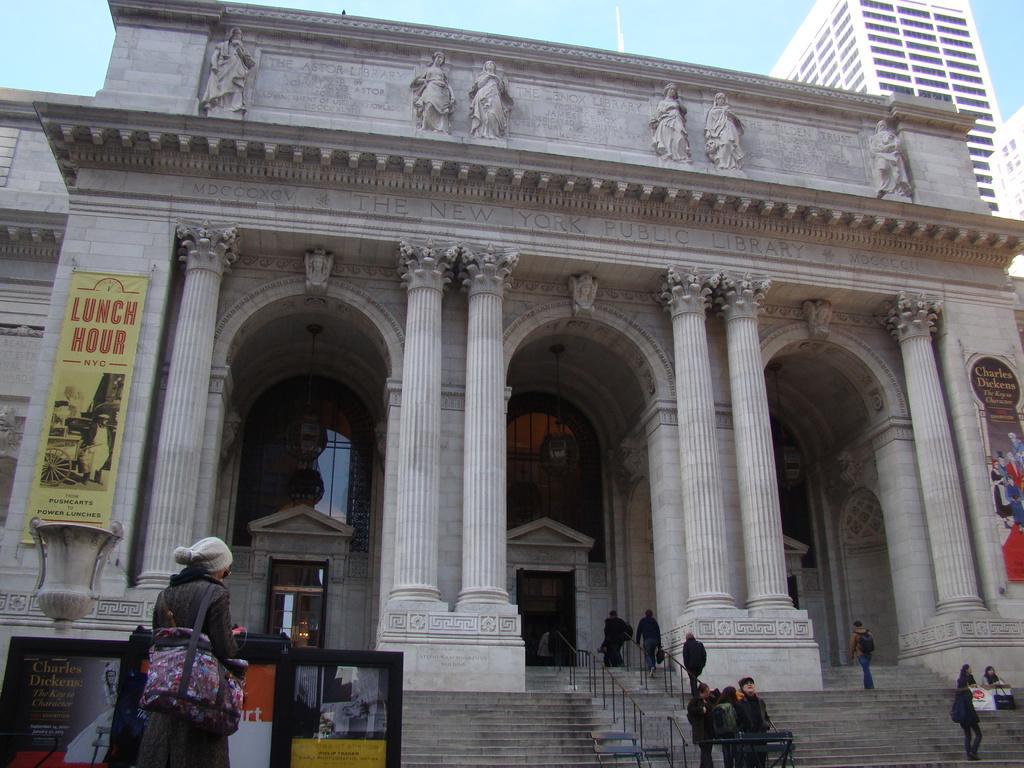In one or two sentences, can you explain what this image depicts? In this image in the center there is one building and also we could see some statues and boards, at the bottom there are some stairs and some persons. In the background there are some buildings, at the top of the image there is sky. 